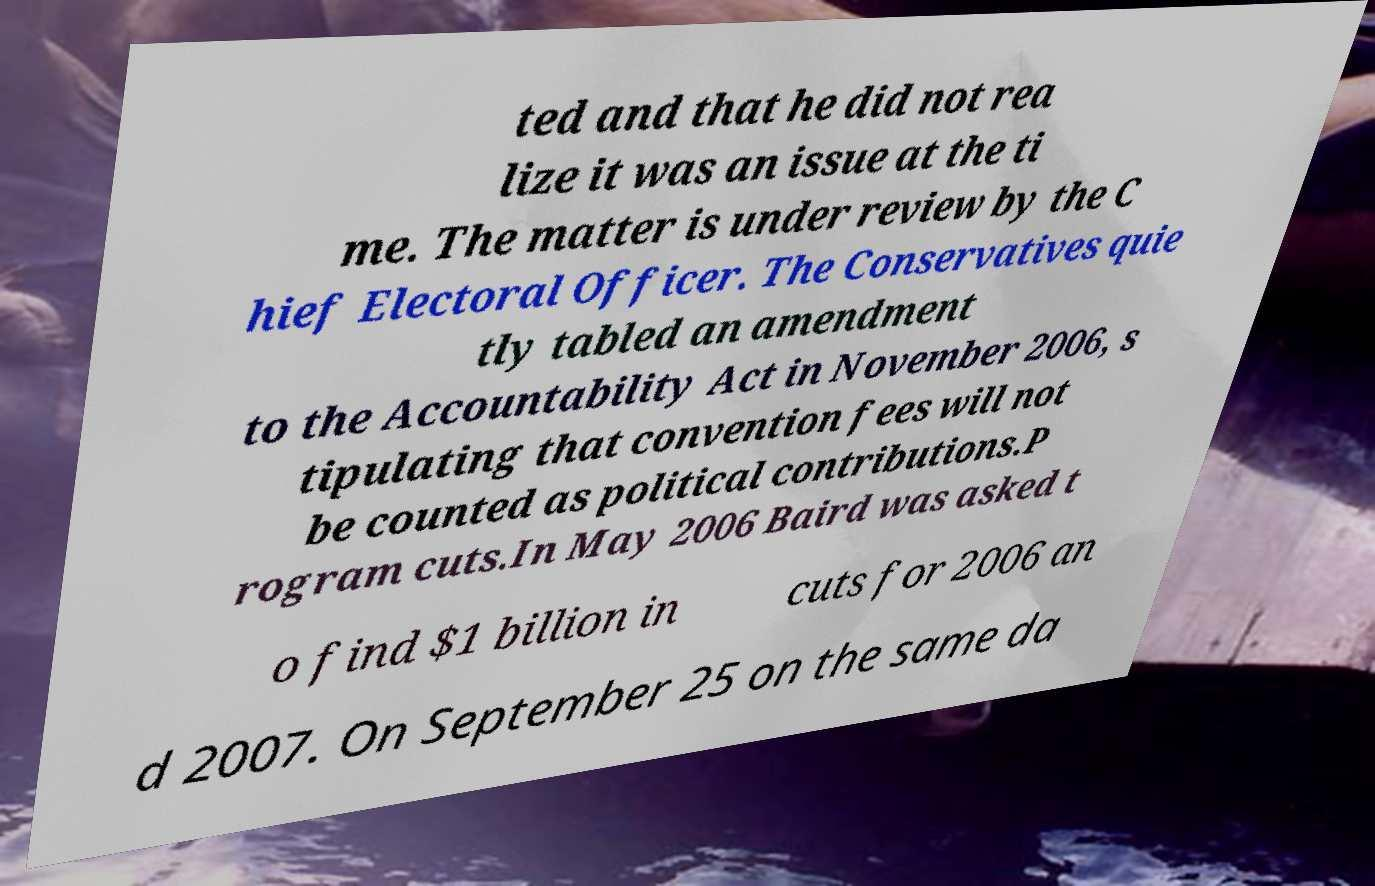I need the written content from this picture converted into text. Can you do that? ted and that he did not rea lize it was an issue at the ti me. The matter is under review by the C hief Electoral Officer. The Conservatives quie tly tabled an amendment to the Accountability Act in November 2006, s tipulating that convention fees will not be counted as political contributions.P rogram cuts.In May 2006 Baird was asked t o find $1 billion in cuts for 2006 an d 2007. On September 25 on the same da 